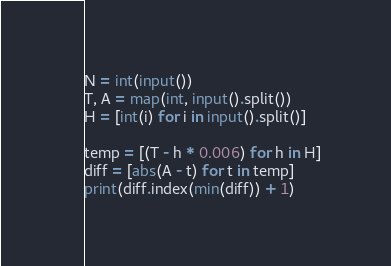Convert code to text. <code><loc_0><loc_0><loc_500><loc_500><_Python_>N = int(input())
T, A = map(int, input().split())
H = [int(i) for i in input().split()]

temp = [(T - h * 0.006) for h in H]
diff = [abs(A - t) for t in temp]
print(diff.index(min(diff)) + 1)
</code> 